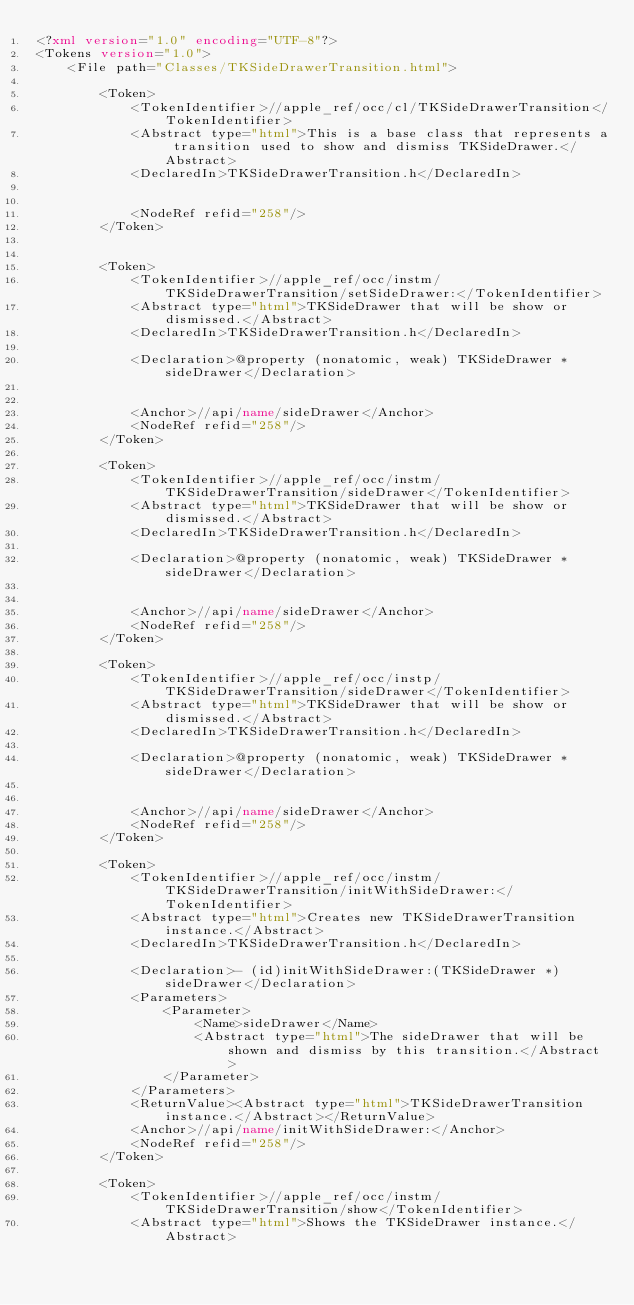Convert code to text. <code><loc_0><loc_0><loc_500><loc_500><_XML_><?xml version="1.0" encoding="UTF-8"?>
<Tokens version="1.0">
	<File path="Classes/TKSideDrawerTransition.html">
		
		<Token>
			<TokenIdentifier>//apple_ref/occ/cl/TKSideDrawerTransition</TokenIdentifier>
			<Abstract type="html">This is a base class that represents a transition used to show and dismiss TKSideDrawer.</Abstract>
			<DeclaredIn>TKSideDrawerTransition.h</DeclaredIn>
            
			
			<NodeRef refid="258"/>
		</Token>
		
		
		<Token>
			<TokenIdentifier>//apple_ref/occ/instm/TKSideDrawerTransition/setSideDrawer:</TokenIdentifier>
			<Abstract type="html">TKSideDrawer that will be show or dismissed.</Abstract>
			<DeclaredIn>TKSideDrawerTransition.h</DeclaredIn>
			
			<Declaration>@property (nonatomic, weak) TKSideDrawer *sideDrawer</Declaration>
			
			
			<Anchor>//api/name/sideDrawer</Anchor>
            <NodeRef refid="258"/>
		</Token>
		
		<Token>
			<TokenIdentifier>//apple_ref/occ/instm/TKSideDrawerTransition/sideDrawer</TokenIdentifier>
			<Abstract type="html">TKSideDrawer that will be show or dismissed.</Abstract>
			<DeclaredIn>TKSideDrawerTransition.h</DeclaredIn>
			
			<Declaration>@property (nonatomic, weak) TKSideDrawer *sideDrawer</Declaration>
			
			
			<Anchor>//api/name/sideDrawer</Anchor>
            <NodeRef refid="258"/>
		</Token>
		
		<Token>
			<TokenIdentifier>//apple_ref/occ/instp/TKSideDrawerTransition/sideDrawer</TokenIdentifier>
			<Abstract type="html">TKSideDrawer that will be show or dismissed.</Abstract>
			<DeclaredIn>TKSideDrawerTransition.h</DeclaredIn>
			
			<Declaration>@property (nonatomic, weak) TKSideDrawer *sideDrawer</Declaration>
			
			
			<Anchor>//api/name/sideDrawer</Anchor>
            <NodeRef refid="258"/>
		</Token>
		
		<Token>
			<TokenIdentifier>//apple_ref/occ/instm/TKSideDrawerTransition/initWithSideDrawer:</TokenIdentifier>
			<Abstract type="html">Creates new TKSideDrawerTransition instance.</Abstract>
			<DeclaredIn>TKSideDrawerTransition.h</DeclaredIn>
			
			<Declaration>- (id)initWithSideDrawer:(TKSideDrawer *)sideDrawer</Declaration>
			<Parameters>
				<Parameter>
					<Name>sideDrawer</Name>
					<Abstract type="html">The sideDrawer that will be shown and dismiss by this transition.</Abstract>
				</Parameter>
			</Parameters>
			<ReturnValue><Abstract type="html">TKSideDrawerTransition instance.</Abstract></ReturnValue>
			<Anchor>//api/name/initWithSideDrawer:</Anchor>
            <NodeRef refid="258"/>
		</Token>
		
		<Token>
			<TokenIdentifier>//apple_ref/occ/instm/TKSideDrawerTransition/show</TokenIdentifier>
			<Abstract type="html">Shows the TKSideDrawer instance.</Abstract></code> 